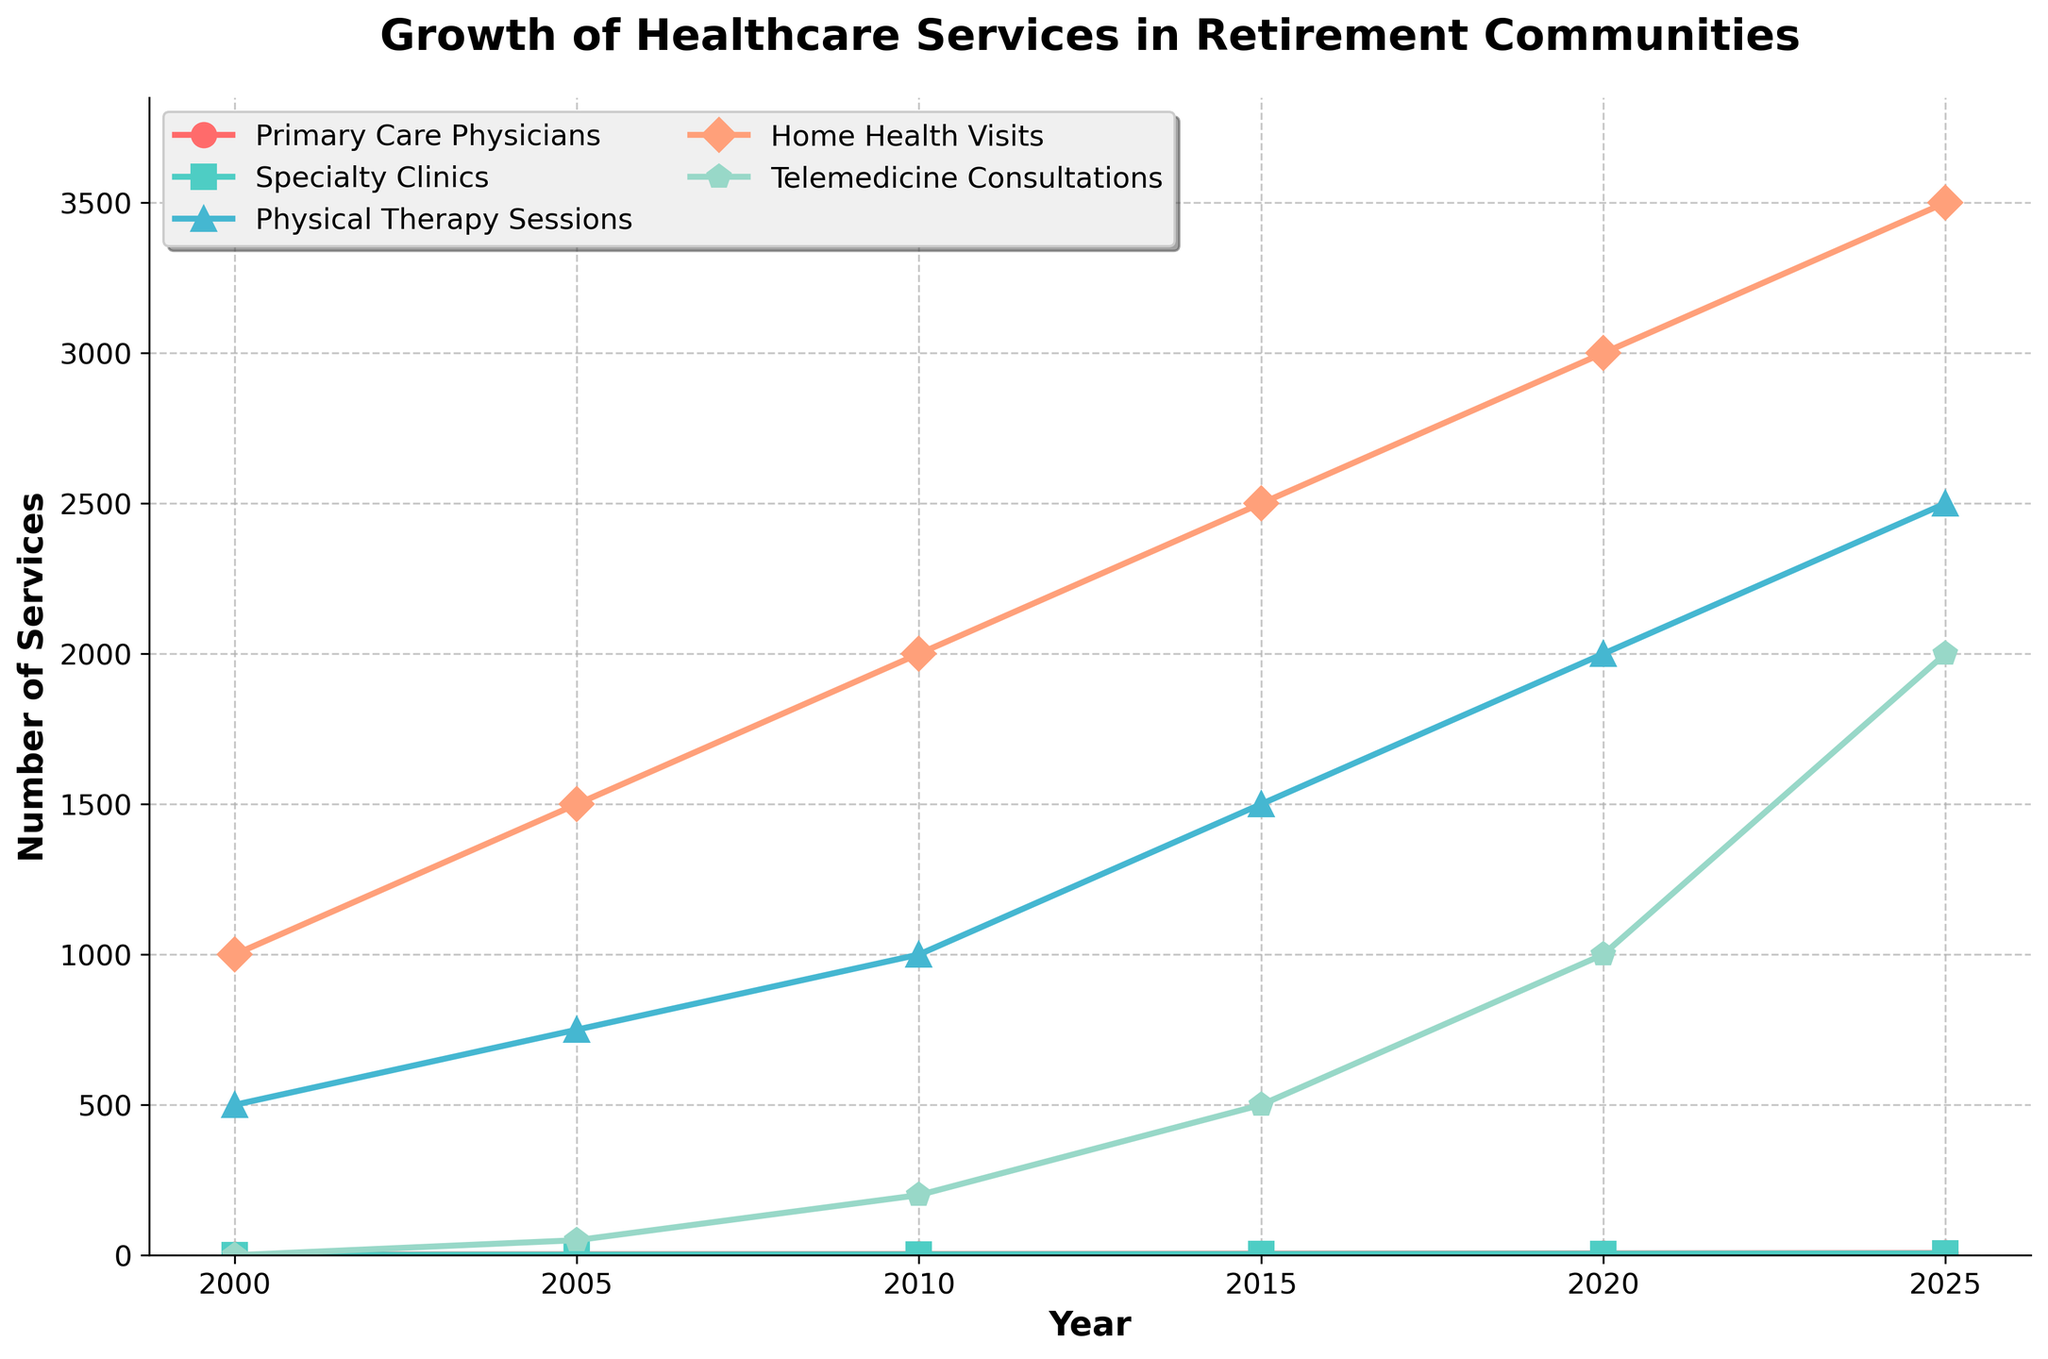What's the total number of healthcare services offered in 2020? Sum the values for each service in 2020: Primary Care Physicians (6) + Specialty Clinics (5) + Physical Therapy Sessions (2000) + Home Health Visits (3000) + Telemedicine Consultations (1000). Total = 6 + 5 + 2000 + 3000 + 1000
Answer: 6011 Which service saw the highest growth between 2000 and 2025? Compare the values for each service in 2000 and 2025. Look at the difference: Primary Care Physicians (7-2), Specialty Clinics (6-1), Physical Therapy Sessions (2500-500), Home Health Visits (3500-1000), and Telemedicine Consultations (2000-0). Physical Therapy Sessions grew by 2000 and had the highest growth
Answer: Physical Therapy Sessions How many more Telemedicine Consultations were there in 2025 compared to 2010? Subtract the number in 2010 from the number in 2025: 2025 (2000) - 2010 (200). Difference = 2000 - 200
Answer: 1800 Between which two consecutive years did Home Health Visits increase the most? Calculate the difference for each period: 2000-2005 (1500-1000 = 500), 2005-2010 (2000-1500 = 500), 2010-2015 (2500-2000 = 500), 2015-2020 (3000-2500 = 500), 2020-2025 (3500-3000 = 500). Since all differences are equal, pick any one period: 2000-2005
Answer: 2000-2005 What is the average number of Specialty Clinics offered from 2000 to 2025? Add the number of Specialty Clinics for each year and then divide by the number of years. (1 + 2 + 3 + 4 + 5 + 6) / 6 = 21 / 6
Answer: 3.5 In which year did Physical Therapy Sessions first surpass 1000 sessions? Identify the year when the number of Physical Therapy Sessions transitions from less than 1000 to more than 1000. In 2010 there are exactly 1000 sessions; in 2015 it surpasses 1000
Answer: 2015 Which service has the largest visual marker in 2025 on the line chart and what shape is it? Identify the marker shape and the relative size for each service in 2025. The "Telemedicine Consultations" has a pentagon shape. It's the largest visual marker
Answer: Pentagon How many years did it take for Primary Care Physicians to increase from 2 to 6? Note the number of Primary Care Physicians in 2000 and in 2020. The difference in years is 2020 - 2000 = 20
Answer: 20 Compare the number of Physical Therapy Sessions and Home Health Visits in 2015. Which is higher? Look at the values for these services in 2015: Physical Therapy Sessions (1500) and Home Health Visits (2500). Home Health Visits is higher
Answer: Home Health Visits What was the increase in Telemedicine Consultations from 2005 to 2015? Subtract the number in 2005 from the number in 2015: 2015 (500) - 2005 (50). Difference = 500 - 50
Answer: 450 